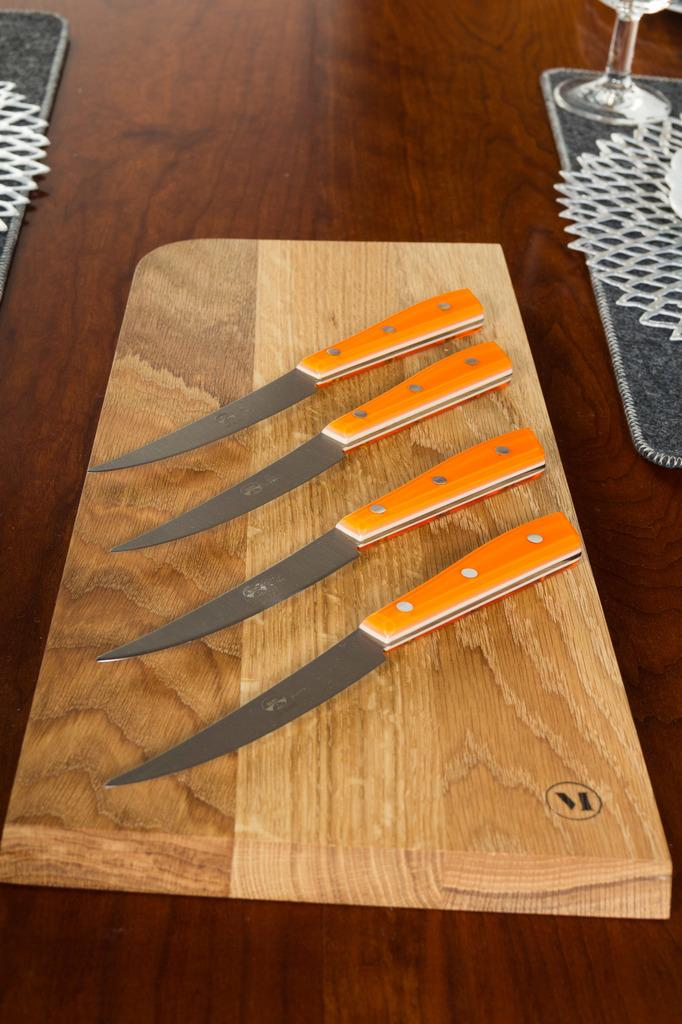How many knives are visible in the image? There are four knives in the image. Where are the knives located? The knives are on a wooden table. What else can be seen on the wooden table? There is a glass on the right side of the image. What type of beef is being served on the wooden table in the image? There is no beef present in the image; the image only shows four knives and a glass on a wooden table. 